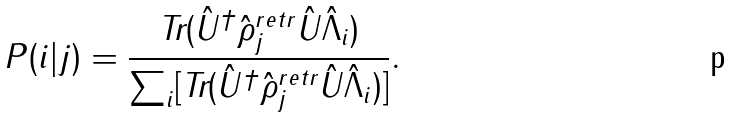<formula> <loc_0><loc_0><loc_500><loc_500>P ( i | j ) = \frac { \text {Tr} ( \hat { U } ^ { \dagger } \hat { \rho } _ { j } ^ { r e t r } \hat { U } \hat { \Lambda } _ { i } ) } { \sum _ { i } [ \text {Tr} ( \hat { U } ^ { \dagger } \hat { \rho } _ { j } ^ { r e t r } \hat { U } \hat { \Lambda } _ { i } ) ] } .</formula> 